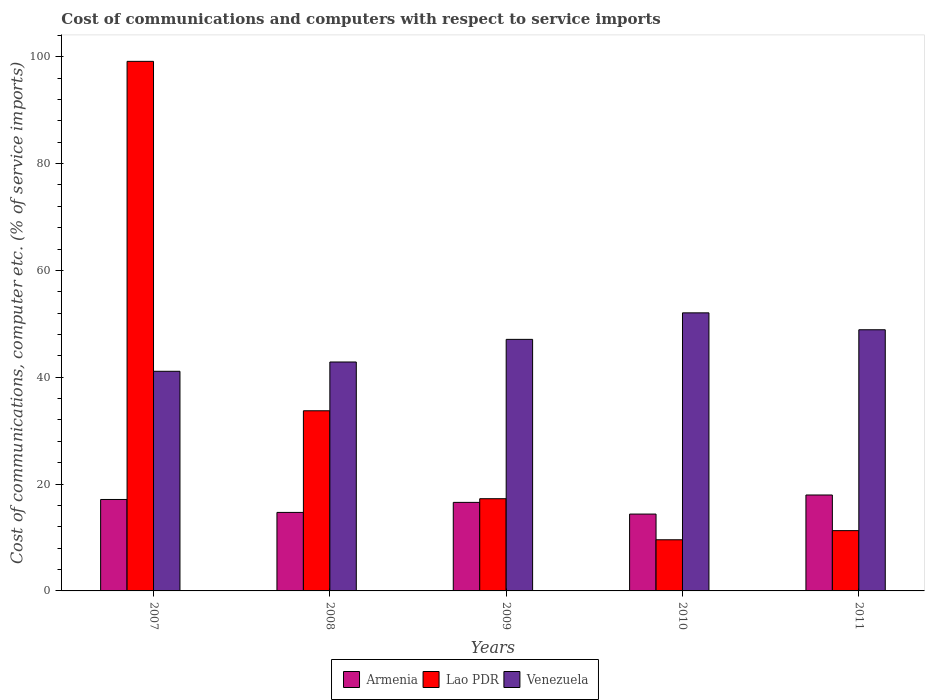Are the number of bars on each tick of the X-axis equal?
Your response must be concise. Yes. How many bars are there on the 2nd tick from the left?
Provide a succinct answer. 3. In how many cases, is the number of bars for a given year not equal to the number of legend labels?
Provide a succinct answer. 0. What is the cost of communications and computers in Venezuela in 2008?
Make the answer very short. 42.85. Across all years, what is the maximum cost of communications and computers in Venezuela?
Your answer should be compact. 52.05. Across all years, what is the minimum cost of communications and computers in Armenia?
Give a very brief answer. 14.39. In which year was the cost of communications and computers in Armenia maximum?
Your response must be concise. 2011. In which year was the cost of communications and computers in Lao PDR minimum?
Give a very brief answer. 2010. What is the total cost of communications and computers in Armenia in the graph?
Ensure brevity in your answer.  80.73. What is the difference between the cost of communications and computers in Armenia in 2008 and that in 2010?
Provide a short and direct response. 0.31. What is the difference between the cost of communications and computers in Lao PDR in 2007 and the cost of communications and computers in Armenia in 2009?
Offer a very short reply. 82.55. What is the average cost of communications and computers in Lao PDR per year?
Your answer should be very brief. 34.19. In the year 2007, what is the difference between the cost of communications and computers in Lao PDR and cost of communications and computers in Armenia?
Your answer should be compact. 82.01. In how many years, is the cost of communications and computers in Venezuela greater than 96 %?
Give a very brief answer. 0. What is the ratio of the cost of communications and computers in Venezuela in 2009 to that in 2010?
Keep it short and to the point. 0.9. Is the cost of communications and computers in Lao PDR in 2007 less than that in 2010?
Make the answer very short. No. What is the difference between the highest and the second highest cost of communications and computers in Armenia?
Keep it short and to the point. 0.84. What is the difference between the highest and the lowest cost of communications and computers in Venezuela?
Make the answer very short. 10.94. Is the sum of the cost of communications and computers in Armenia in 2007 and 2008 greater than the maximum cost of communications and computers in Lao PDR across all years?
Provide a short and direct response. No. What does the 3rd bar from the left in 2010 represents?
Offer a terse response. Venezuela. What does the 1st bar from the right in 2010 represents?
Keep it short and to the point. Venezuela. Is it the case that in every year, the sum of the cost of communications and computers in Armenia and cost of communications and computers in Venezuela is greater than the cost of communications and computers in Lao PDR?
Your response must be concise. No. How many years are there in the graph?
Make the answer very short. 5. What is the difference between two consecutive major ticks on the Y-axis?
Make the answer very short. 20. Are the values on the major ticks of Y-axis written in scientific E-notation?
Keep it short and to the point. No. Does the graph contain grids?
Your answer should be very brief. No. How are the legend labels stacked?
Provide a succinct answer. Horizontal. What is the title of the graph?
Keep it short and to the point. Cost of communications and computers with respect to service imports. What is the label or title of the Y-axis?
Keep it short and to the point. Cost of communications, computer etc. (% of service imports). What is the Cost of communications, computer etc. (% of service imports) of Armenia in 2007?
Offer a very short reply. 17.12. What is the Cost of communications, computer etc. (% of service imports) in Lao PDR in 2007?
Your answer should be compact. 99.13. What is the Cost of communications, computer etc. (% of service imports) of Venezuela in 2007?
Your response must be concise. 41.11. What is the Cost of communications, computer etc. (% of service imports) in Armenia in 2008?
Offer a very short reply. 14.7. What is the Cost of communications, computer etc. (% of service imports) of Lao PDR in 2008?
Provide a succinct answer. 33.72. What is the Cost of communications, computer etc. (% of service imports) of Venezuela in 2008?
Provide a succinct answer. 42.85. What is the Cost of communications, computer etc. (% of service imports) of Armenia in 2009?
Your response must be concise. 16.57. What is the Cost of communications, computer etc. (% of service imports) of Lao PDR in 2009?
Your response must be concise. 17.26. What is the Cost of communications, computer etc. (% of service imports) of Venezuela in 2009?
Give a very brief answer. 47.09. What is the Cost of communications, computer etc. (% of service imports) in Armenia in 2010?
Your answer should be very brief. 14.39. What is the Cost of communications, computer etc. (% of service imports) in Lao PDR in 2010?
Give a very brief answer. 9.57. What is the Cost of communications, computer etc. (% of service imports) of Venezuela in 2010?
Offer a very short reply. 52.05. What is the Cost of communications, computer etc. (% of service imports) in Armenia in 2011?
Make the answer very short. 17.96. What is the Cost of communications, computer etc. (% of service imports) of Lao PDR in 2011?
Ensure brevity in your answer.  11.29. What is the Cost of communications, computer etc. (% of service imports) of Venezuela in 2011?
Offer a very short reply. 48.89. Across all years, what is the maximum Cost of communications, computer etc. (% of service imports) of Armenia?
Ensure brevity in your answer.  17.96. Across all years, what is the maximum Cost of communications, computer etc. (% of service imports) in Lao PDR?
Offer a terse response. 99.13. Across all years, what is the maximum Cost of communications, computer etc. (% of service imports) in Venezuela?
Your answer should be very brief. 52.05. Across all years, what is the minimum Cost of communications, computer etc. (% of service imports) of Armenia?
Offer a terse response. 14.39. Across all years, what is the minimum Cost of communications, computer etc. (% of service imports) in Lao PDR?
Your answer should be compact. 9.57. Across all years, what is the minimum Cost of communications, computer etc. (% of service imports) in Venezuela?
Offer a terse response. 41.11. What is the total Cost of communications, computer etc. (% of service imports) of Armenia in the graph?
Provide a short and direct response. 80.73. What is the total Cost of communications, computer etc. (% of service imports) in Lao PDR in the graph?
Give a very brief answer. 170.97. What is the total Cost of communications, computer etc. (% of service imports) in Venezuela in the graph?
Your answer should be very brief. 231.99. What is the difference between the Cost of communications, computer etc. (% of service imports) in Armenia in 2007 and that in 2008?
Your response must be concise. 2.42. What is the difference between the Cost of communications, computer etc. (% of service imports) in Lao PDR in 2007 and that in 2008?
Keep it short and to the point. 65.41. What is the difference between the Cost of communications, computer etc. (% of service imports) in Venezuela in 2007 and that in 2008?
Provide a succinct answer. -1.74. What is the difference between the Cost of communications, computer etc. (% of service imports) of Armenia in 2007 and that in 2009?
Your response must be concise. 0.54. What is the difference between the Cost of communications, computer etc. (% of service imports) of Lao PDR in 2007 and that in 2009?
Offer a very short reply. 81.87. What is the difference between the Cost of communications, computer etc. (% of service imports) of Venezuela in 2007 and that in 2009?
Make the answer very short. -5.97. What is the difference between the Cost of communications, computer etc. (% of service imports) of Armenia in 2007 and that in 2010?
Ensure brevity in your answer.  2.73. What is the difference between the Cost of communications, computer etc. (% of service imports) in Lao PDR in 2007 and that in 2010?
Offer a very short reply. 89.56. What is the difference between the Cost of communications, computer etc. (% of service imports) of Venezuela in 2007 and that in 2010?
Provide a short and direct response. -10.94. What is the difference between the Cost of communications, computer etc. (% of service imports) of Armenia in 2007 and that in 2011?
Your response must be concise. -0.84. What is the difference between the Cost of communications, computer etc. (% of service imports) in Lao PDR in 2007 and that in 2011?
Provide a succinct answer. 87.84. What is the difference between the Cost of communications, computer etc. (% of service imports) in Venezuela in 2007 and that in 2011?
Make the answer very short. -7.77. What is the difference between the Cost of communications, computer etc. (% of service imports) in Armenia in 2008 and that in 2009?
Offer a terse response. -1.88. What is the difference between the Cost of communications, computer etc. (% of service imports) in Lao PDR in 2008 and that in 2009?
Provide a succinct answer. 16.46. What is the difference between the Cost of communications, computer etc. (% of service imports) of Venezuela in 2008 and that in 2009?
Offer a very short reply. -4.23. What is the difference between the Cost of communications, computer etc. (% of service imports) in Armenia in 2008 and that in 2010?
Provide a succinct answer. 0.31. What is the difference between the Cost of communications, computer etc. (% of service imports) in Lao PDR in 2008 and that in 2010?
Provide a succinct answer. 24.15. What is the difference between the Cost of communications, computer etc. (% of service imports) in Venezuela in 2008 and that in 2010?
Provide a succinct answer. -9.2. What is the difference between the Cost of communications, computer etc. (% of service imports) of Armenia in 2008 and that in 2011?
Your answer should be very brief. -3.26. What is the difference between the Cost of communications, computer etc. (% of service imports) in Lao PDR in 2008 and that in 2011?
Offer a very short reply. 22.43. What is the difference between the Cost of communications, computer etc. (% of service imports) of Venezuela in 2008 and that in 2011?
Make the answer very short. -6.03. What is the difference between the Cost of communications, computer etc. (% of service imports) of Armenia in 2009 and that in 2010?
Provide a short and direct response. 2.19. What is the difference between the Cost of communications, computer etc. (% of service imports) in Lao PDR in 2009 and that in 2010?
Offer a very short reply. 7.69. What is the difference between the Cost of communications, computer etc. (% of service imports) in Venezuela in 2009 and that in 2010?
Make the answer very short. -4.96. What is the difference between the Cost of communications, computer etc. (% of service imports) in Armenia in 2009 and that in 2011?
Ensure brevity in your answer.  -1.38. What is the difference between the Cost of communications, computer etc. (% of service imports) of Lao PDR in 2009 and that in 2011?
Offer a terse response. 5.98. What is the difference between the Cost of communications, computer etc. (% of service imports) of Venezuela in 2009 and that in 2011?
Your response must be concise. -1.8. What is the difference between the Cost of communications, computer etc. (% of service imports) in Armenia in 2010 and that in 2011?
Give a very brief answer. -3.57. What is the difference between the Cost of communications, computer etc. (% of service imports) of Lao PDR in 2010 and that in 2011?
Give a very brief answer. -1.71. What is the difference between the Cost of communications, computer etc. (% of service imports) in Venezuela in 2010 and that in 2011?
Your answer should be very brief. 3.16. What is the difference between the Cost of communications, computer etc. (% of service imports) in Armenia in 2007 and the Cost of communications, computer etc. (% of service imports) in Lao PDR in 2008?
Provide a short and direct response. -16.6. What is the difference between the Cost of communications, computer etc. (% of service imports) of Armenia in 2007 and the Cost of communications, computer etc. (% of service imports) of Venezuela in 2008?
Give a very brief answer. -25.74. What is the difference between the Cost of communications, computer etc. (% of service imports) of Lao PDR in 2007 and the Cost of communications, computer etc. (% of service imports) of Venezuela in 2008?
Give a very brief answer. 56.28. What is the difference between the Cost of communications, computer etc. (% of service imports) in Armenia in 2007 and the Cost of communications, computer etc. (% of service imports) in Lao PDR in 2009?
Keep it short and to the point. -0.14. What is the difference between the Cost of communications, computer etc. (% of service imports) of Armenia in 2007 and the Cost of communications, computer etc. (% of service imports) of Venezuela in 2009?
Your response must be concise. -29.97. What is the difference between the Cost of communications, computer etc. (% of service imports) of Lao PDR in 2007 and the Cost of communications, computer etc. (% of service imports) of Venezuela in 2009?
Provide a short and direct response. 52.04. What is the difference between the Cost of communications, computer etc. (% of service imports) of Armenia in 2007 and the Cost of communications, computer etc. (% of service imports) of Lao PDR in 2010?
Give a very brief answer. 7.54. What is the difference between the Cost of communications, computer etc. (% of service imports) in Armenia in 2007 and the Cost of communications, computer etc. (% of service imports) in Venezuela in 2010?
Make the answer very short. -34.94. What is the difference between the Cost of communications, computer etc. (% of service imports) of Lao PDR in 2007 and the Cost of communications, computer etc. (% of service imports) of Venezuela in 2010?
Give a very brief answer. 47.08. What is the difference between the Cost of communications, computer etc. (% of service imports) in Armenia in 2007 and the Cost of communications, computer etc. (% of service imports) in Lao PDR in 2011?
Your answer should be compact. 5.83. What is the difference between the Cost of communications, computer etc. (% of service imports) in Armenia in 2007 and the Cost of communications, computer etc. (% of service imports) in Venezuela in 2011?
Keep it short and to the point. -31.77. What is the difference between the Cost of communications, computer etc. (% of service imports) in Lao PDR in 2007 and the Cost of communications, computer etc. (% of service imports) in Venezuela in 2011?
Offer a terse response. 50.24. What is the difference between the Cost of communications, computer etc. (% of service imports) in Armenia in 2008 and the Cost of communications, computer etc. (% of service imports) in Lao PDR in 2009?
Give a very brief answer. -2.56. What is the difference between the Cost of communications, computer etc. (% of service imports) in Armenia in 2008 and the Cost of communications, computer etc. (% of service imports) in Venezuela in 2009?
Keep it short and to the point. -32.39. What is the difference between the Cost of communications, computer etc. (% of service imports) of Lao PDR in 2008 and the Cost of communications, computer etc. (% of service imports) of Venezuela in 2009?
Give a very brief answer. -13.37. What is the difference between the Cost of communications, computer etc. (% of service imports) in Armenia in 2008 and the Cost of communications, computer etc. (% of service imports) in Lao PDR in 2010?
Offer a terse response. 5.12. What is the difference between the Cost of communications, computer etc. (% of service imports) of Armenia in 2008 and the Cost of communications, computer etc. (% of service imports) of Venezuela in 2010?
Keep it short and to the point. -37.36. What is the difference between the Cost of communications, computer etc. (% of service imports) in Lao PDR in 2008 and the Cost of communications, computer etc. (% of service imports) in Venezuela in 2010?
Provide a succinct answer. -18.33. What is the difference between the Cost of communications, computer etc. (% of service imports) of Armenia in 2008 and the Cost of communications, computer etc. (% of service imports) of Lao PDR in 2011?
Provide a short and direct response. 3.41. What is the difference between the Cost of communications, computer etc. (% of service imports) in Armenia in 2008 and the Cost of communications, computer etc. (% of service imports) in Venezuela in 2011?
Your response must be concise. -34.19. What is the difference between the Cost of communications, computer etc. (% of service imports) in Lao PDR in 2008 and the Cost of communications, computer etc. (% of service imports) in Venezuela in 2011?
Keep it short and to the point. -15.17. What is the difference between the Cost of communications, computer etc. (% of service imports) in Armenia in 2009 and the Cost of communications, computer etc. (% of service imports) in Lao PDR in 2010?
Ensure brevity in your answer.  7. What is the difference between the Cost of communications, computer etc. (% of service imports) of Armenia in 2009 and the Cost of communications, computer etc. (% of service imports) of Venezuela in 2010?
Give a very brief answer. -35.48. What is the difference between the Cost of communications, computer etc. (% of service imports) in Lao PDR in 2009 and the Cost of communications, computer etc. (% of service imports) in Venezuela in 2010?
Offer a terse response. -34.79. What is the difference between the Cost of communications, computer etc. (% of service imports) of Armenia in 2009 and the Cost of communications, computer etc. (% of service imports) of Lao PDR in 2011?
Your answer should be compact. 5.29. What is the difference between the Cost of communications, computer etc. (% of service imports) of Armenia in 2009 and the Cost of communications, computer etc. (% of service imports) of Venezuela in 2011?
Your answer should be compact. -32.31. What is the difference between the Cost of communications, computer etc. (% of service imports) of Lao PDR in 2009 and the Cost of communications, computer etc. (% of service imports) of Venezuela in 2011?
Give a very brief answer. -31.63. What is the difference between the Cost of communications, computer etc. (% of service imports) of Armenia in 2010 and the Cost of communications, computer etc. (% of service imports) of Lao PDR in 2011?
Offer a terse response. 3.1. What is the difference between the Cost of communications, computer etc. (% of service imports) of Armenia in 2010 and the Cost of communications, computer etc. (% of service imports) of Venezuela in 2011?
Offer a terse response. -34.5. What is the difference between the Cost of communications, computer etc. (% of service imports) in Lao PDR in 2010 and the Cost of communications, computer etc. (% of service imports) in Venezuela in 2011?
Make the answer very short. -39.31. What is the average Cost of communications, computer etc. (% of service imports) in Armenia per year?
Provide a short and direct response. 16.15. What is the average Cost of communications, computer etc. (% of service imports) of Lao PDR per year?
Offer a very short reply. 34.19. What is the average Cost of communications, computer etc. (% of service imports) of Venezuela per year?
Provide a short and direct response. 46.4. In the year 2007, what is the difference between the Cost of communications, computer etc. (% of service imports) of Armenia and Cost of communications, computer etc. (% of service imports) of Lao PDR?
Offer a terse response. -82.01. In the year 2007, what is the difference between the Cost of communications, computer etc. (% of service imports) in Armenia and Cost of communications, computer etc. (% of service imports) in Venezuela?
Make the answer very short. -24. In the year 2007, what is the difference between the Cost of communications, computer etc. (% of service imports) in Lao PDR and Cost of communications, computer etc. (% of service imports) in Venezuela?
Your response must be concise. 58.02. In the year 2008, what is the difference between the Cost of communications, computer etc. (% of service imports) in Armenia and Cost of communications, computer etc. (% of service imports) in Lao PDR?
Your response must be concise. -19.02. In the year 2008, what is the difference between the Cost of communications, computer etc. (% of service imports) of Armenia and Cost of communications, computer etc. (% of service imports) of Venezuela?
Keep it short and to the point. -28.16. In the year 2008, what is the difference between the Cost of communications, computer etc. (% of service imports) of Lao PDR and Cost of communications, computer etc. (% of service imports) of Venezuela?
Offer a terse response. -9.13. In the year 2009, what is the difference between the Cost of communications, computer etc. (% of service imports) in Armenia and Cost of communications, computer etc. (% of service imports) in Lao PDR?
Offer a terse response. -0.69. In the year 2009, what is the difference between the Cost of communications, computer etc. (% of service imports) in Armenia and Cost of communications, computer etc. (% of service imports) in Venezuela?
Make the answer very short. -30.51. In the year 2009, what is the difference between the Cost of communications, computer etc. (% of service imports) of Lao PDR and Cost of communications, computer etc. (% of service imports) of Venezuela?
Your response must be concise. -29.83. In the year 2010, what is the difference between the Cost of communications, computer etc. (% of service imports) in Armenia and Cost of communications, computer etc. (% of service imports) in Lao PDR?
Make the answer very short. 4.81. In the year 2010, what is the difference between the Cost of communications, computer etc. (% of service imports) of Armenia and Cost of communications, computer etc. (% of service imports) of Venezuela?
Give a very brief answer. -37.67. In the year 2010, what is the difference between the Cost of communications, computer etc. (% of service imports) in Lao PDR and Cost of communications, computer etc. (% of service imports) in Venezuela?
Provide a short and direct response. -42.48. In the year 2011, what is the difference between the Cost of communications, computer etc. (% of service imports) of Armenia and Cost of communications, computer etc. (% of service imports) of Lao PDR?
Your answer should be very brief. 6.67. In the year 2011, what is the difference between the Cost of communications, computer etc. (% of service imports) in Armenia and Cost of communications, computer etc. (% of service imports) in Venezuela?
Make the answer very short. -30.93. In the year 2011, what is the difference between the Cost of communications, computer etc. (% of service imports) of Lao PDR and Cost of communications, computer etc. (% of service imports) of Venezuela?
Ensure brevity in your answer.  -37.6. What is the ratio of the Cost of communications, computer etc. (% of service imports) in Armenia in 2007 to that in 2008?
Make the answer very short. 1.16. What is the ratio of the Cost of communications, computer etc. (% of service imports) in Lao PDR in 2007 to that in 2008?
Make the answer very short. 2.94. What is the ratio of the Cost of communications, computer etc. (% of service imports) in Venezuela in 2007 to that in 2008?
Make the answer very short. 0.96. What is the ratio of the Cost of communications, computer etc. (% of service imports) of Armenia in 2007 to that in 2009?
Ensure brevity in your answer.  1.03. What is the ratio of the Cost of communications, computer etc. (% of service imports) in Lao PDR in 2007 to that in 2009?
Provide a short and direct response. 5.74. What is the ratio of the Cost of communications, computer etc. (% of service imports) in Venezuela in 2007 to that in 2009?
Give a very brief answer. 0.87. What is the ratio of the Cost of communications, computer etc. (% of service imports) of Armenia in 2007 to that in 2010?
Make the answer very short. 1.19. What is the ratio of the Cost of communications, computer etc. (% of service imports) of Lao PDR in 2007 to that in 2010?
Your answer should be compact. 10.35. What is the ratio of the Cost of communications, computer etc. (% of service imports) in Venezuela in 2007 to that in 2010?
Provide a short and direct response. 0.79. What is the ratio of the Cost of communications, computer etc. (% of service imports) in Armenia in 2007 to that in 2011?
Keep it short and to the point. 0.95. What is the ratio of the Cost of communications, computer etc. (% of service imports) in Lao PDR in 2007 to that in 2011?
Your response must be concise. 8.78. What is the ratio of the Cost of communications, computer etc. (% of service imports) in Venezuela in 2007 to that in 2011?
Offer a very short reply. 0.84. What is the ratio of the Cost of communications, computer etc. (% of service imports) in Armenia in 2008 to that in 2009?
Your answer should be compact. 0.89. What is the ratio of the Cost of communications, computer etc. (% of service imports) of Lao PDR in 2008 to that in 2009?
Ensure brevity in your answer.  1.95. What is the ratio of the Cost of communications, computer etc. (% of service imports) in Venezuela in 2008 to that in 2009?
Provide a short and direct response. 0.91. What is the ratio of the Cost of communications, computer etc. (% of service imports) of Armenia in 2008 to that in 2010?
Ensure brevity in your answer.  1.02. What is the ratio of the Cost of communications, computer etc. (% of service imports) of Lao PDR in 2008 to that in 2010?
Your answer should be compact. 3.52. What is the ratio of the Cost of communications, computer etc. (% of service imports) of Venezuela in 2008 to that in 2010?
Your answer should be compact. 0.82. What is the ratio of the Cost of communications, computer etc. (% of service imports) of Armenia in 2008 to that in 2011?
Provide a short and direct response. 0.82. What is the ratio of the Cost of communications, computer etc. (% of service imports) of Lao PDR in 2008 to that in 2011?
Give a very brief answer. 2.99. What is the ratio of the Cost of communications, computer etc. (% of service imports) in Venezuela in 2008 to that in 2011?
Your answer should be very brief. 0.88. What is the ratio of the Cost of communications, computer etc. (% of service imports) of Armenia in 2009 to that in 2010?
Your response must be concise. 1.15. What is the ratio of the Cost of communications, computer etc. (% of service imports) of Lao PDR in 2009 to that in 2010?
Your response must be concise. 1.8. What is the ratio of the Cost of communications, computer etc. (% of service imports) of Venezuela in 2009 to that in 2010?
Your response must be concise. 0.9. What is the ratio of the Cost of communications, computer etc. (% of service imports) of Armenia in 2009 to that in 2011?
Ensure brevity in your answer.  0.92. What is the ratio of the Cost of communications, computer etc. (% of service imports) in Lao PDR in 2009 to that in 2011?
Your response must be concise. 1.53. What is the ratio of the Cost of communications, computer etc. (% of service imports) of Venezuela in 2009 to that in 2011?
Provide a short and direct response. 0.96. What is the ratio of the Cost of communications, computer etc. (% of service imports) of Armenia in 2010 to that in 2011?
Keep it short and to the point. 0.8. What is the ratio of the Cost of communications, computer etc. (% of service imports) of Lao PDR in 2010 to that in 2011?
Provide a short and direct response. 0.85. What is the ratio of the Cost of communications, computer etc. (% of service imports) of Venezuela in 2010 to that in 2011?
Keep it short and to the point. 1.06. What is the difference between the highest and the second highest Cost of communications, computer etc. (% of service imports) of Armenia?
Make the answer very short. 0.84. What is the difference between the highest and the second highest Cost of communications, computer etc. (% of service imports) in Lao PDR?
Give a very brief answer. 65.41. What is the difference between the highest and the second highest Cost of communications, computer etc. (% of service imports) of Venezuela?
Your response must be concise. 3.16. What is the difference between the highest and the lowest Cost of communications, computer etc. (% of service imports) of Armenia?
Offer a very short reply. 3.57. What is the difference between the highest and the lowest Cost of communications, computer etc. (% of service imports) in Lao PDR?
Keep it short and to the point. 89.56. What is the difference between the highest and the lowest Cost of communications, computer etc. (% of service imports) of Venezuela?
Your answer should be very brief. 10.94. 